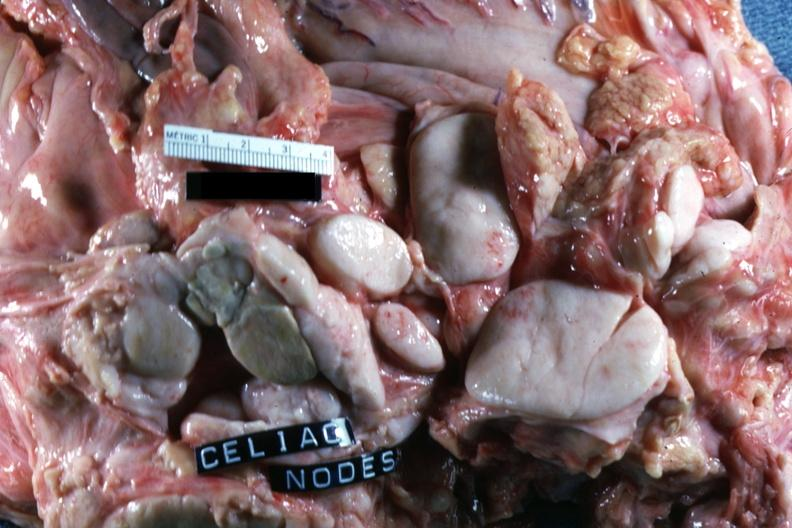does tuberculosis show sectioned nodes with ivory white color?
Answer the question using a single word or phrase. No 